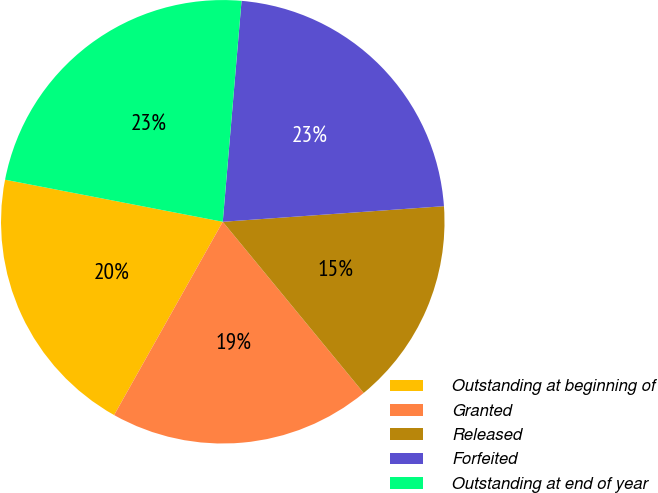Convert chart to OTSL. <chart><loc_0><loc_0><loc_500><loc_500><pie_chart><fcel>Outstanding at beginning of<fcel>Granted<fcel>Released<fcel>Forfeited<fcel>Outstanding at end of year<nl><fcel>19.89%<fcel>19.11%<fcel>15.16%<fcel>22.53%<fcel>23.31%<nl></chart> 